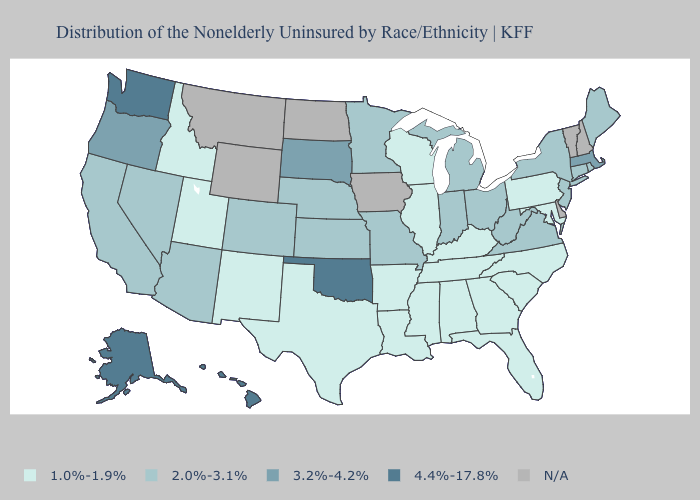Does Virginia have the highest value in the USA?
Concise answer only. No. Which states have the lowest value in the USA?
Give a very brief answer. Alabama, Arkansas, Florida, Georgia, Idaho, Illinois, Kentucky, Louisiana, Maryland, Mississippi, New Mexico, North Carolina, Pennsylvania, South Carolina, Tennessee, Texas, Utah, Wisconsin. What is the value of Connecticut?
Keep it brief. 2.0%-3.1%. Name the states that have a value in the range 3.2%-4.2%?
Keep it brief. Massachusetts, Oregon, South Dakota. Name the states that have a value in the range 3.2%-4.2%?
Write a very short answer. Massachusetts, Oregon, South Dakota. What is the highest value in states that border New York?
Short answer required. 3.2%-4.2%. What is the value of Mississippi?
Give a very brief answer. 1.0%-1.9%. Does South Dakota have the highest value in the MidWest?
Answer briefly. Yes. Which states have the lowest value in the West?
Quick response, please. Idaho, New Mexico, Utah. Name the states that have a value in the range 4.4%-17.8%?
Short answer required. Alaska, Hawaii, Oklahoma, Washington. Among the states that border Wyoming , which have the lowest value?
Quick response, please. Idaho, Utah. What is the value of Pennsylvania?
Short answer required. 1.0%-1.9%. Name the states that have a value in the range 3.2%-4.2%?
Keep it brief. Massachusetts, Oregon, South Dakota. Name the states that have a value in the range 3.2%-4.2%?
Short answer required. Massachusetts, Oregon, South Dakota. 